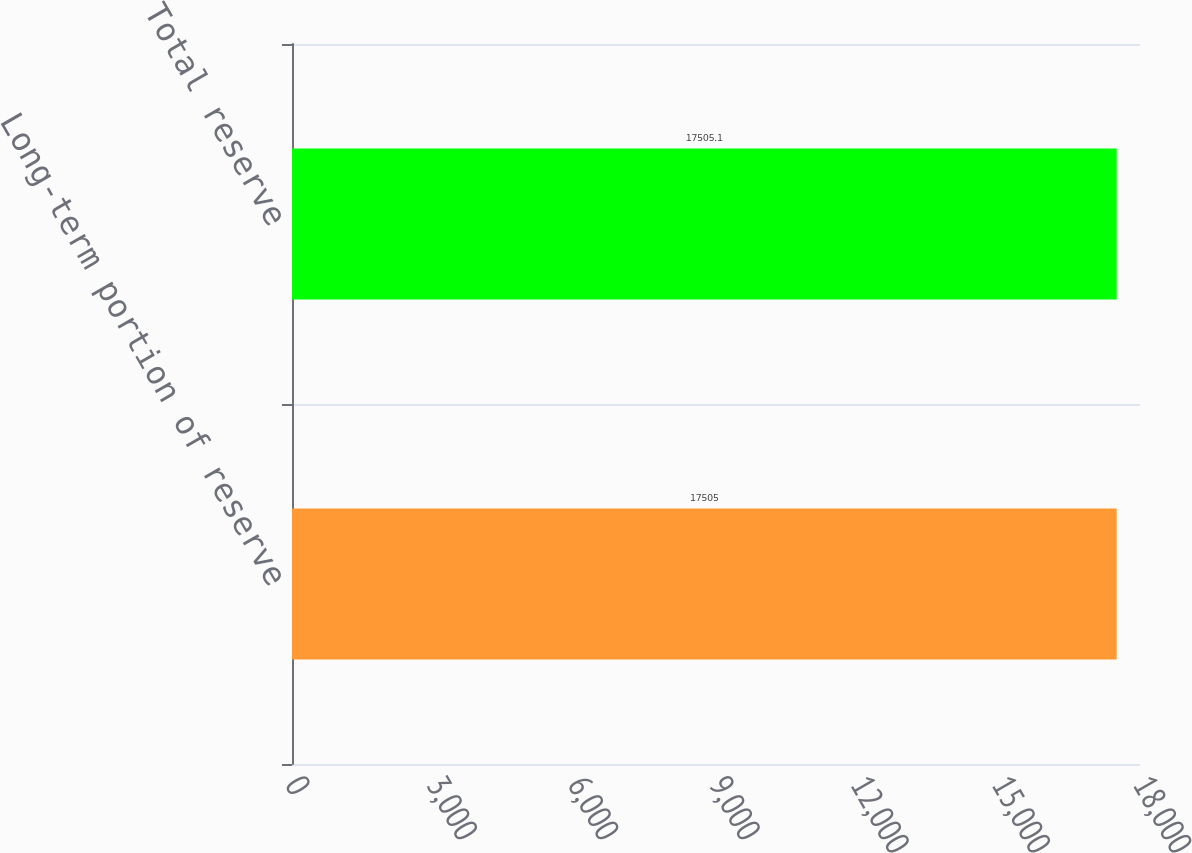Convert chart. <chart><loc_0><loc_0><loc_500><loc_500><bar_chart><fcel>Long-term portion of reserve<fcel>Total reserve<nl><fcel>17505<fcel>17505.1<nl></chart> 